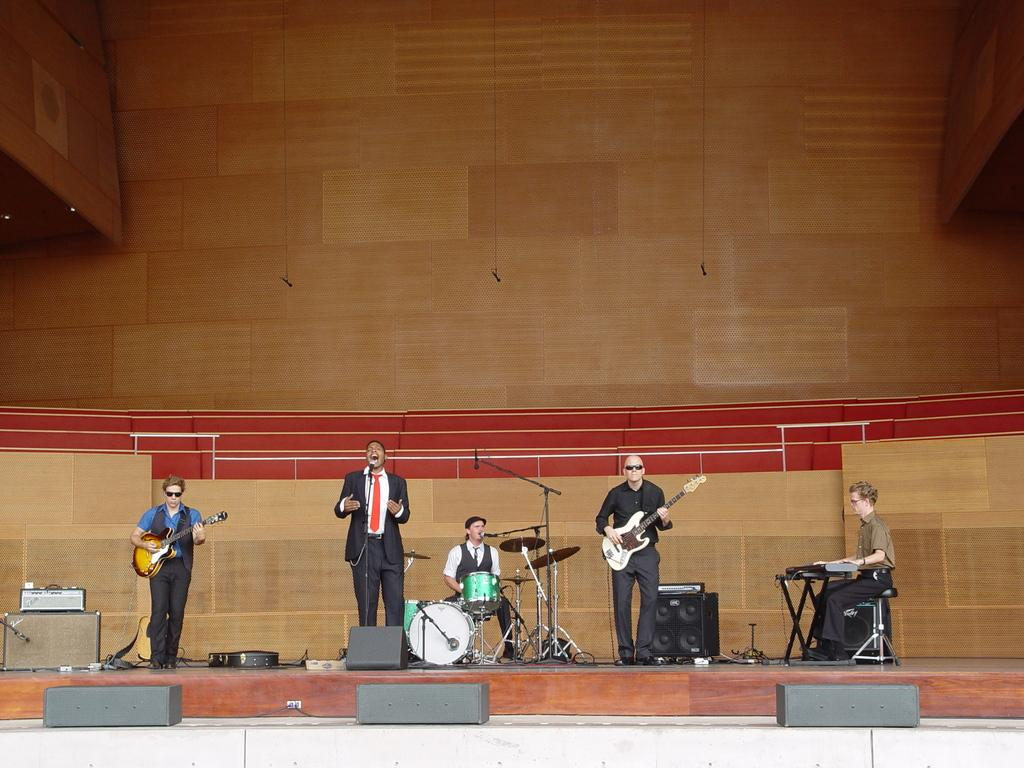Who is present in the image? There are people in the image. What are the people doing in the image? The people are standing and playing musical instruments. Where are the people located in the image? The people are on a stage. What type of cannon is being fired on the stage in the image? There is no cannon present in the image; the people are playing musical instruments on the stage. 